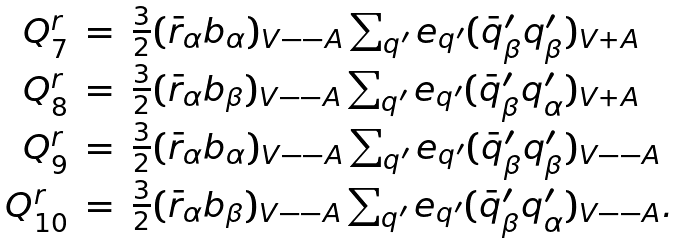Convert formula to latex. <formula><loc_0><loc_0><loc_500><loc_500>\begin{array} { r c l } Q _ { 7 } ^ { r } & = & \frac { 3 } { 2 } ( \bar { r } _ { \alpha } b _ { \alpha } ) _ { V - - A } \sum _ { q ^ { \prime } } e _ { q ^ { \prime } } ( \bar { q } ^ { \prime } _ { \beta } q ^ { \prime } _ { \beta } ) _ { V + A } \\ Q _ { 8 } ^ { r } & = & \frac { 3 } { 2 } ( \bar { r } _ { \alpha } b _ { \beta } ) _ { V - - A } \sum _ { q ^ { \prime } } e _ { q ^ { \prime } } ( \bar { q } _ { \beta } ^ { \prime } q ^ { \prime } _ { \alpha } ) _ { V + A } \\ Q _ { 9 } ^ { r } & = & \frac { 3 } { 2 } ( \bar { r } _ { \alpha } b _ { \alpha } ) _ { V - - A } \sum _ { q ^ { \prime } } e _ { q ^ { \prime } } ( \bar { q } ^ { \prime } _ { \beta } q ^ { \prime } _ { \beta } ) _ { V - - A } \\ Q _ { 1 0 } ^ { r } & = & \frac { 3 } { 2 } ( \bar { r } _ { \alpha } b _ { \beta } ) _ { V - - A } \sum _ { q ^ { \prime } } e _ { q ^ { \prime } } ( \bar { q } ^ { \prime } _ { \beta } q ^ { \prime } _ { \alpha } ) _ { V - - A } . \end{array}</formula> 